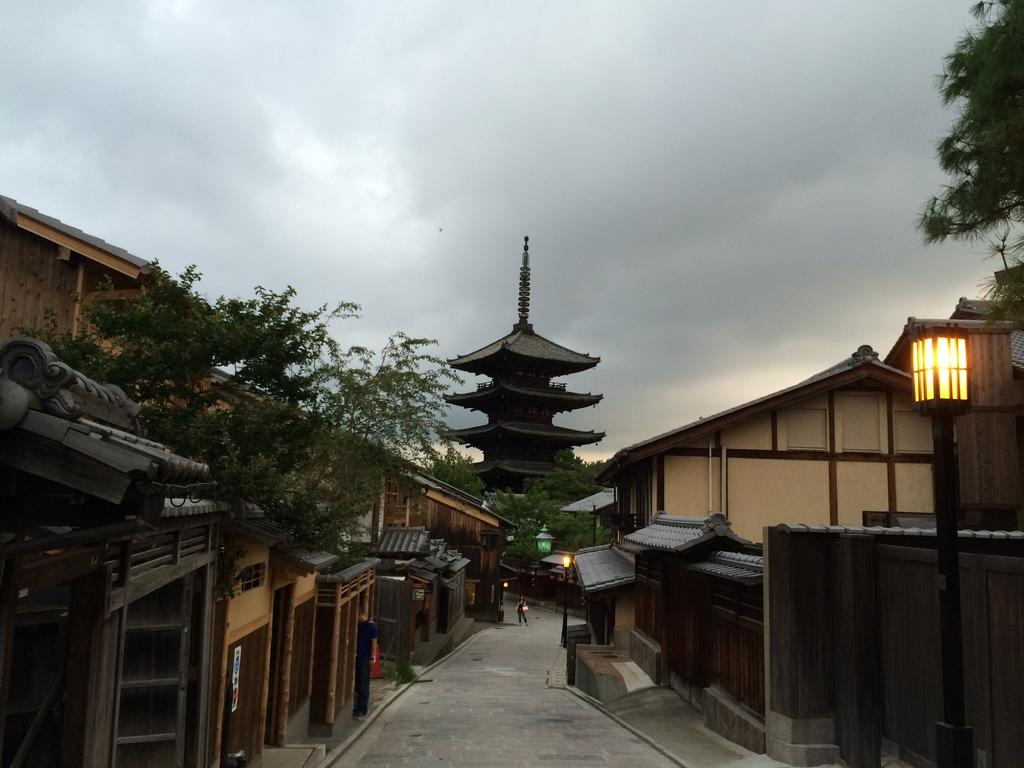What type of structures can be seen in the image? There are buildings in the image. What other natural elements are present in the image? There are trees in the image. What type of artificial lighting can be seen in the image? There are street lights in the image. What type of pathway is visible in the image? There is a road in the image. Can you describe the person in the image? There is a person in the image. What is visible in the sky in the image? The sky is visible in the image, and it is cloudy. Can you tell me how many wrens are perched on the street lights in the image? There are no wrens present in the image; it only features buildings, trees, street lights, a road, a person, and a cloudy sky. What type of sport is being played on the road in the image? There is no sport being played in the image, as it only shows a person, buildings, trees, street lights, a road, and a cloudy sky. 